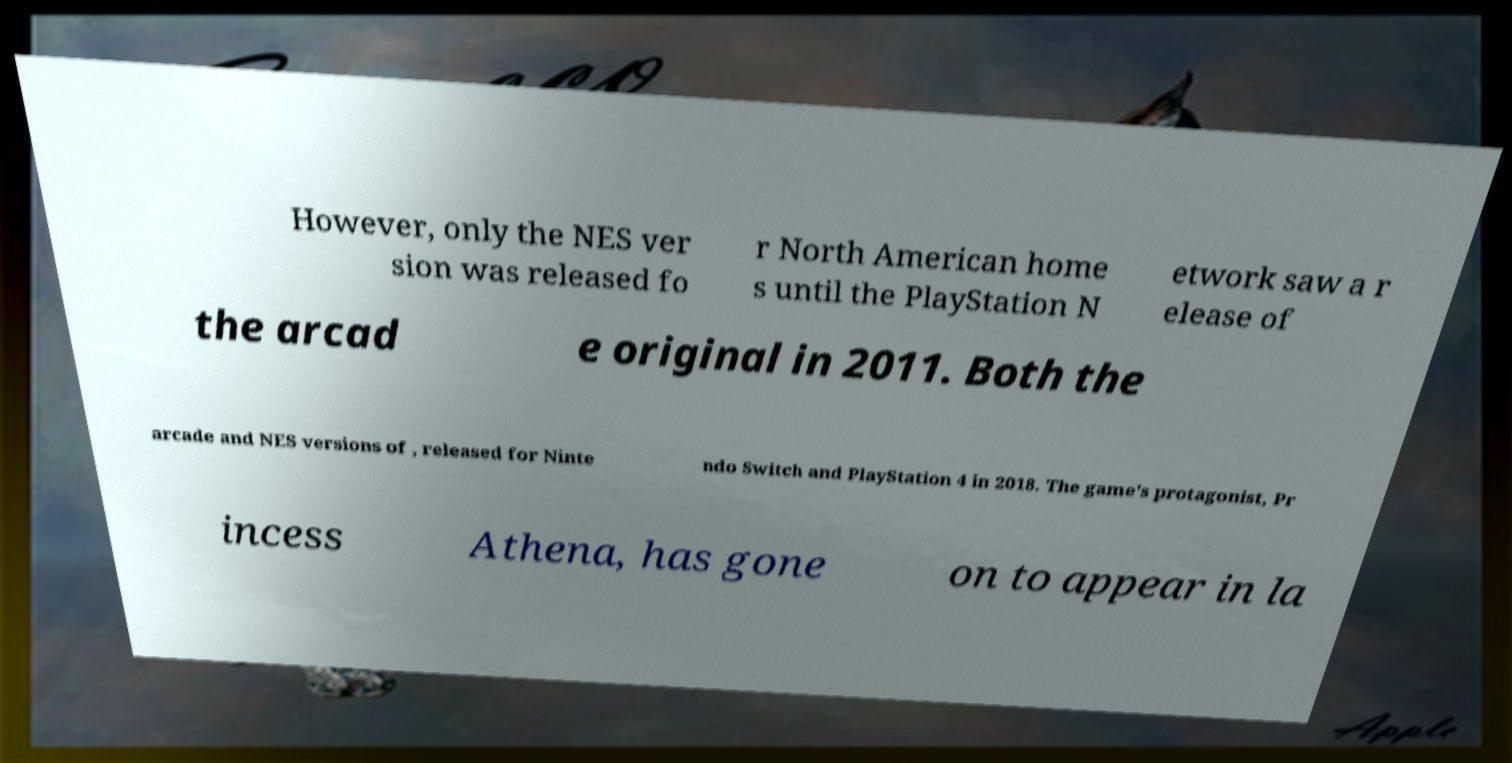For documentation purposes, I need the text within this image transcribed. Could you provide that? However, only the NES ver sion was released fo r North American home s until the PlayStation N etwork saw a r elease of the arcad e original in 2011. Both the arcade and NES versions of , released for Ninte ndo Switch and PlayStation 4 in 2018. The game's protagonist, Pr incess Athena, has gone on to appear in la 